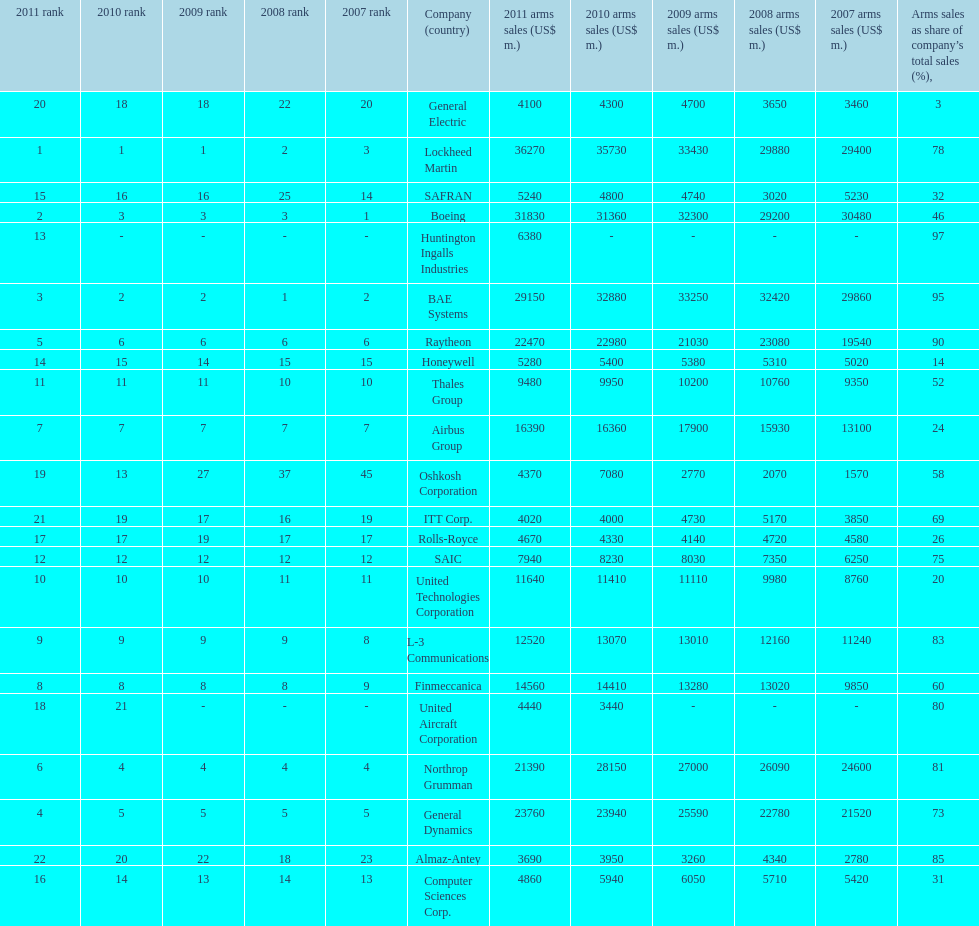In 2010, who has the least amount of sales? United Aircraft Corporation. 